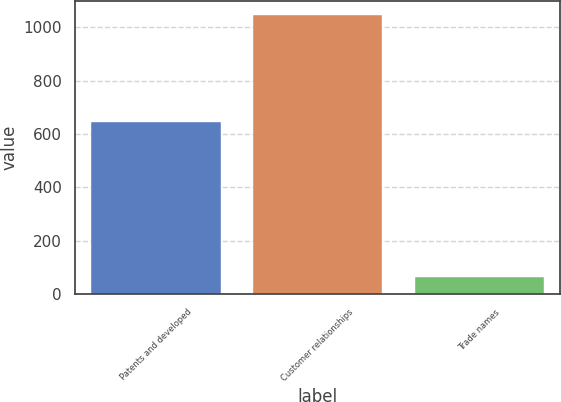<chart> <loc_0><loc_0><loc_500><loc_500><bar_chart><fcel>Patents and developed<fcel>Customer relationships<fcel>Trade names<nl><fcel>647<fcel>1046<fcel>66<nl></chart> 